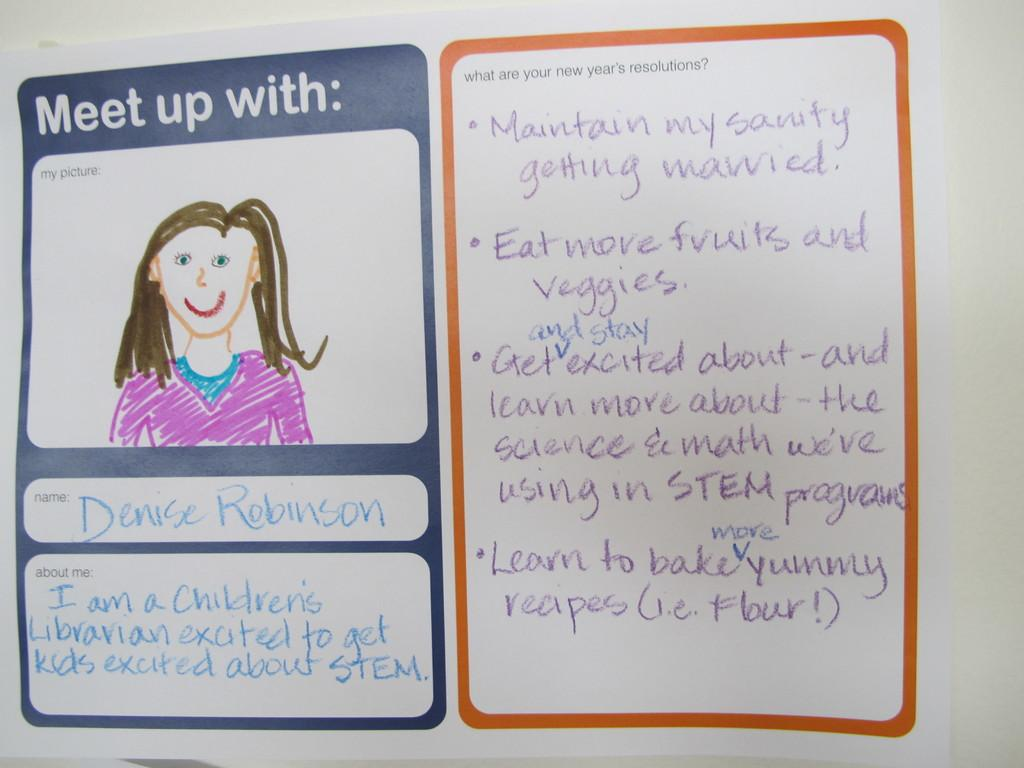What is the main subject in the center of the image? There is a poster in the center of the image. Where is the poster located? The poster is pasted on a wall. What else can be seen in the image besides the poster? There is a painting of a girl and text written on a paper in the image. How many snails are crawling on the poster in the image? There are no snails present in the image. What type of wound is visible on the girl in the painting? There is no girl with a wound in the painting; it is a portrait of a girl without any visible injuries. 